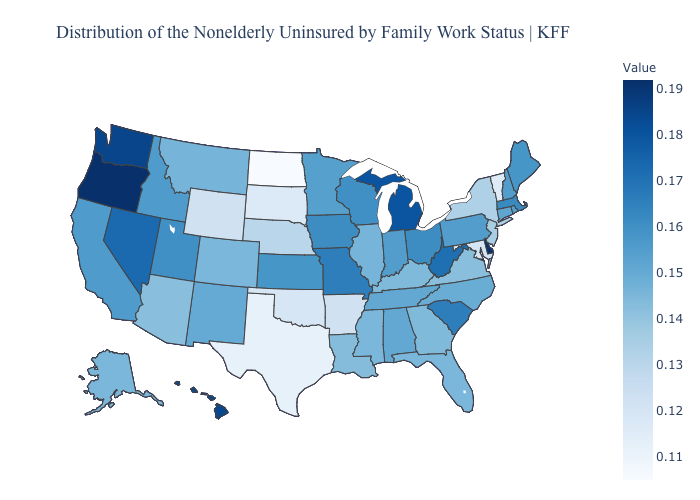Which states have the highest value in the USA?
Write a very short answer. Delaware, Oregon. Does Nevada have the lowest value in the West?
Be succinct. No. Which states hav the highest value in the West?
Short answer required. Oregon. Does Delaware have the highest value in the USA?
Answer briefly. Yes. Which states have the lowest value in the West?
Write a very short answer. Wyoming. 